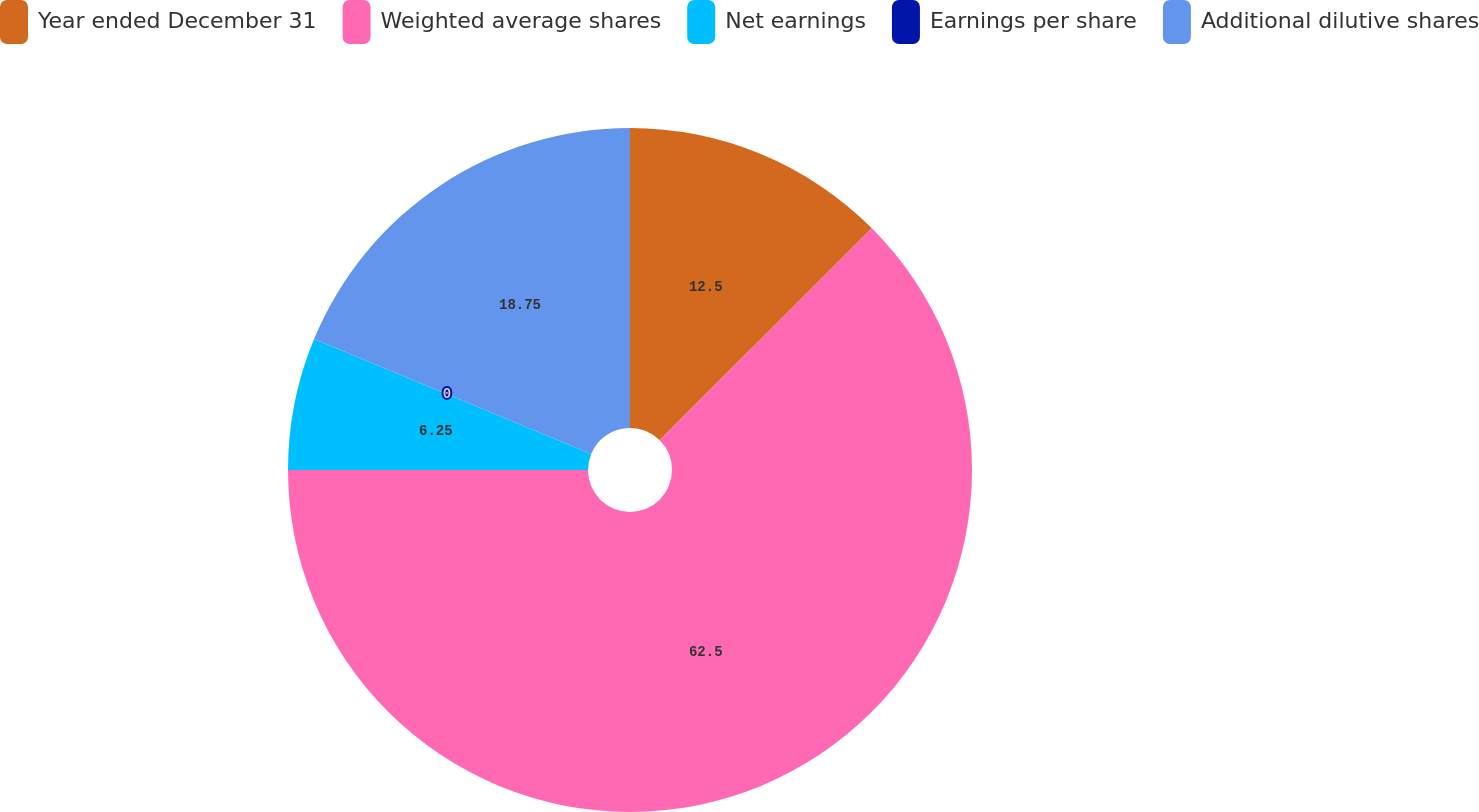Convert chart to OTSL. <chart><loc_0><loc_0><loc_500><loc_500><pie_chart><fcel>Year ended December 31<fcel>Weighted average shares<fcel>Net earnings<fcel>Earnings per share<fcel>Additional dilutive shares<nl><fcel>12.5%<fcel>62.5%<fcel>6.25%<fcel>0.0%<fcel>18.75%<nl></chart> 